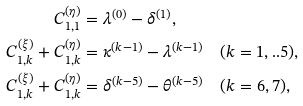<formula> <loc_0><loc_0><loc_500><loc_500>C _ { 1 , 1 } ^ { ( \eta ) } & = \lambda ^ { ( 0 ) } - \delta ^ { ( 1 ) } , \\ C _ { 1 , k } ^ { ( \xi ) } + C _ { 1 , k } ^ { ( \eta ) } & = \kappa ^ { ( k - 1 ) } - \lambda ^ { ( k - 1 ) } \quad ( k = 1 , . . 5 ) , \\ C _ { 1 , k } ^ { ( \xi ) } + C _ { 1 , k } ^ { ( \eta ) } & = \delta ^ { ( k - 5 ) } - \theta ^ { ( k - 5 ) } \quad ( k = 6 , 7 ) ,</formula> 